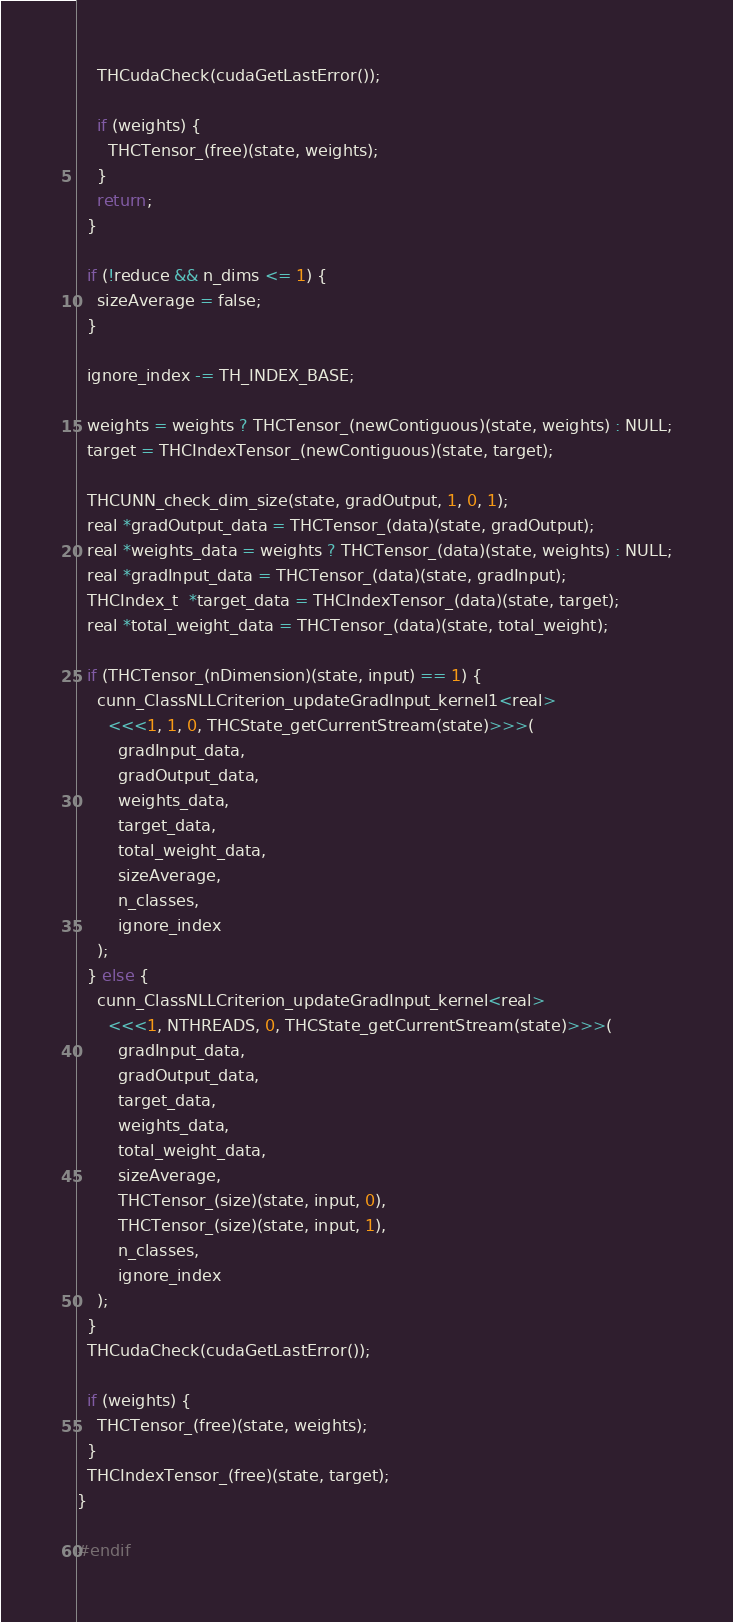<code> <loc_0><loc_0><loc_500><loc_500><_Cuda_>
    THCudaCheck(cudaGetLastError());

    if (weights) {
      THCTensor_(free)(state, weights);
    }
    return;
  }

  if (!reduce && n_dims <= 1) {
    sizeAverage = false;
  }

  ignore_index -= TH_INDEX_BASE;

  weights = weights ? THCTensor_(newContiguous)(state, weights) : NULL;
  target = THCIndexTensor_(newContiguous)(state, target);

  THCUNN_check_dim_size(state, gradOutput, 1, 0, 1);
  real *gradOutput_data = THCTensor_(data)(state, gradOutput);
  real *weights_data = weights ? THCTensor_(data)(state, weights) : NULL;
  real *gradInput_data = THCTensor_(data)(state, gradInput);
  THCIndex_t  *target_data = THCIndexTensor_(data)(state, target);
  real *total_weight_data = THCTensor_(data)(state, total_weight);

  if (THCTensor_(nDimension)(state, input) == 1) {
    cunn_ClassNLLCriterion_updateGradInput_kernel1<real>
      <<<1, 1, 0, THCState_getCurrentStream(state)>>>(
        gradInput_data,
        gradOutput_data,
        weights_data,
        target_data,
        total_weight_data,
        sizeAverage,
        n_classes,
        ignore_index
    );
  } else {
    cunn_ClassNLLCriterion_updateGradInput_kernel<real>
      <<<1, NTHREADS, 0, THCState_getCurrentStream(state)>>>(
        gradInput_data,
        gradOutput_data,
        target_data,
        weights_data,
        total_weight_data,
        sizeAverage,
        THCTensor_(size)(state, input, 0),
        THCTensor_(size)(state, input, 1),
        n_classes,
        ignore_index
    );
  }
  THCudaCheck(cudaGetLastError());

  if (weights) {
    THCTensor_(free)(state, weights);
  }
  THCIndexTensor_(free)(state, target);
}

#endif
</code> 